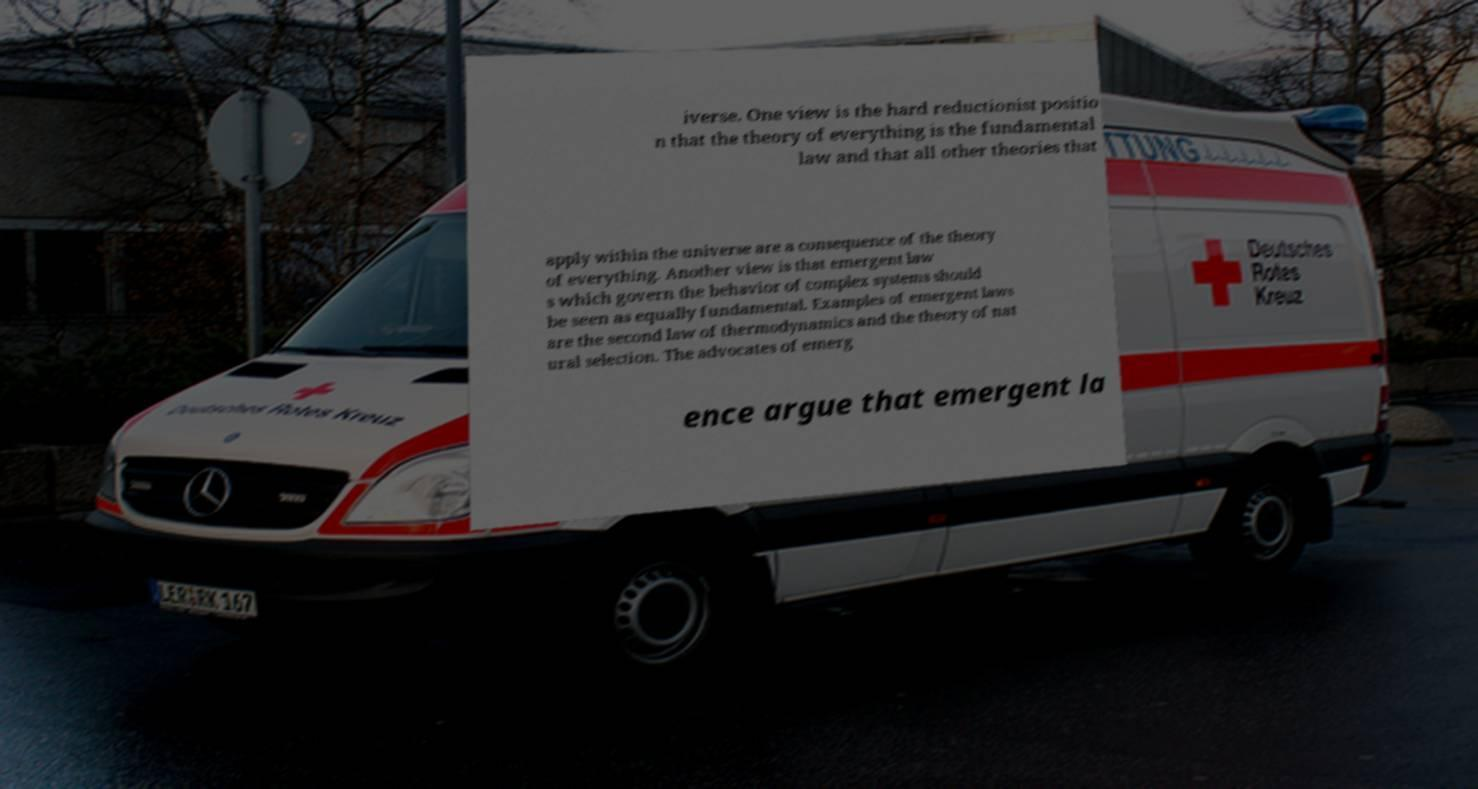Can you read and provide the text displayed in the image?This photo seems to have some interesting text. Can you extract and type it out for me? iverse. One view is the hard reductionist positio n that the theory of everything is the fundamental law and that all other theories that apply within the universe are a consequence of the theory of everything. Another view is that emergent law s which govern the behavior of complex systems should be seen as equally fundamental. Examples of emergent laws are the second law of thermodynamics and the theory of nat ural selection. The advocates of emerg ence argue that emergent la 